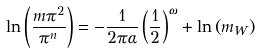<formula> <loc_0><loc_0><loc_500><loc_500>\ln \left ( \frac { m \pi ^ { 2 } } { \pi ^ { n } } \right ) = - \frac { 1 } { 2 \pi \alpha } \left ( \frac { 1 } { 2 } \right ) ^ { \omega } + \ln \left ( m _ { W } \right )</formula> 